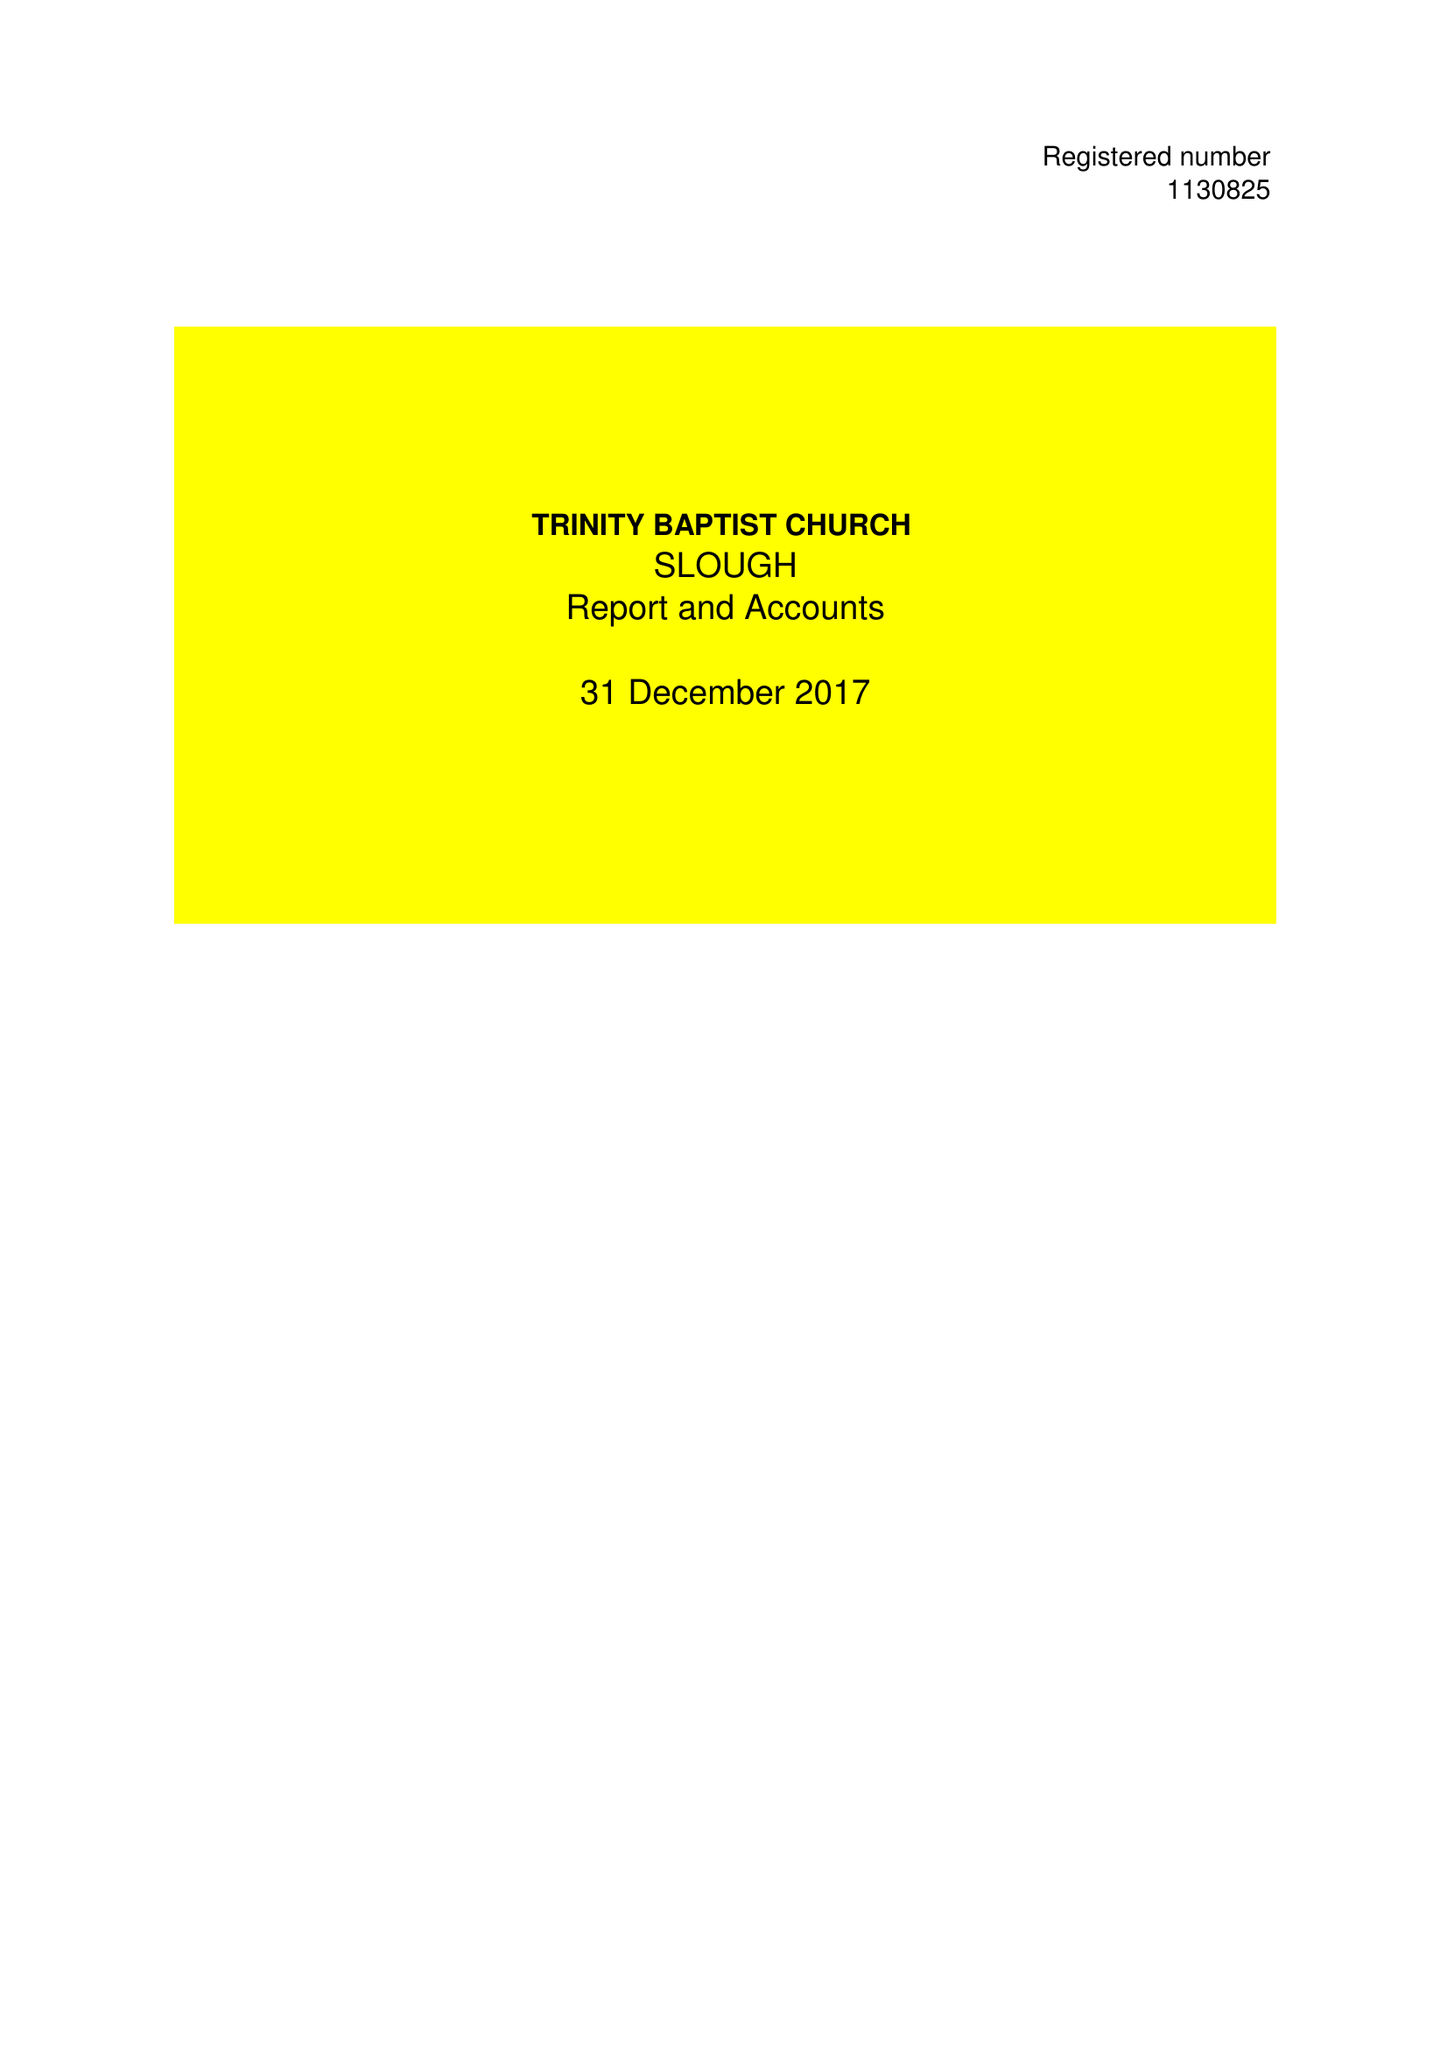What is the value for the charity_name?
Answer the question using a single word or phrase. Trinity Baptist Church Slough 